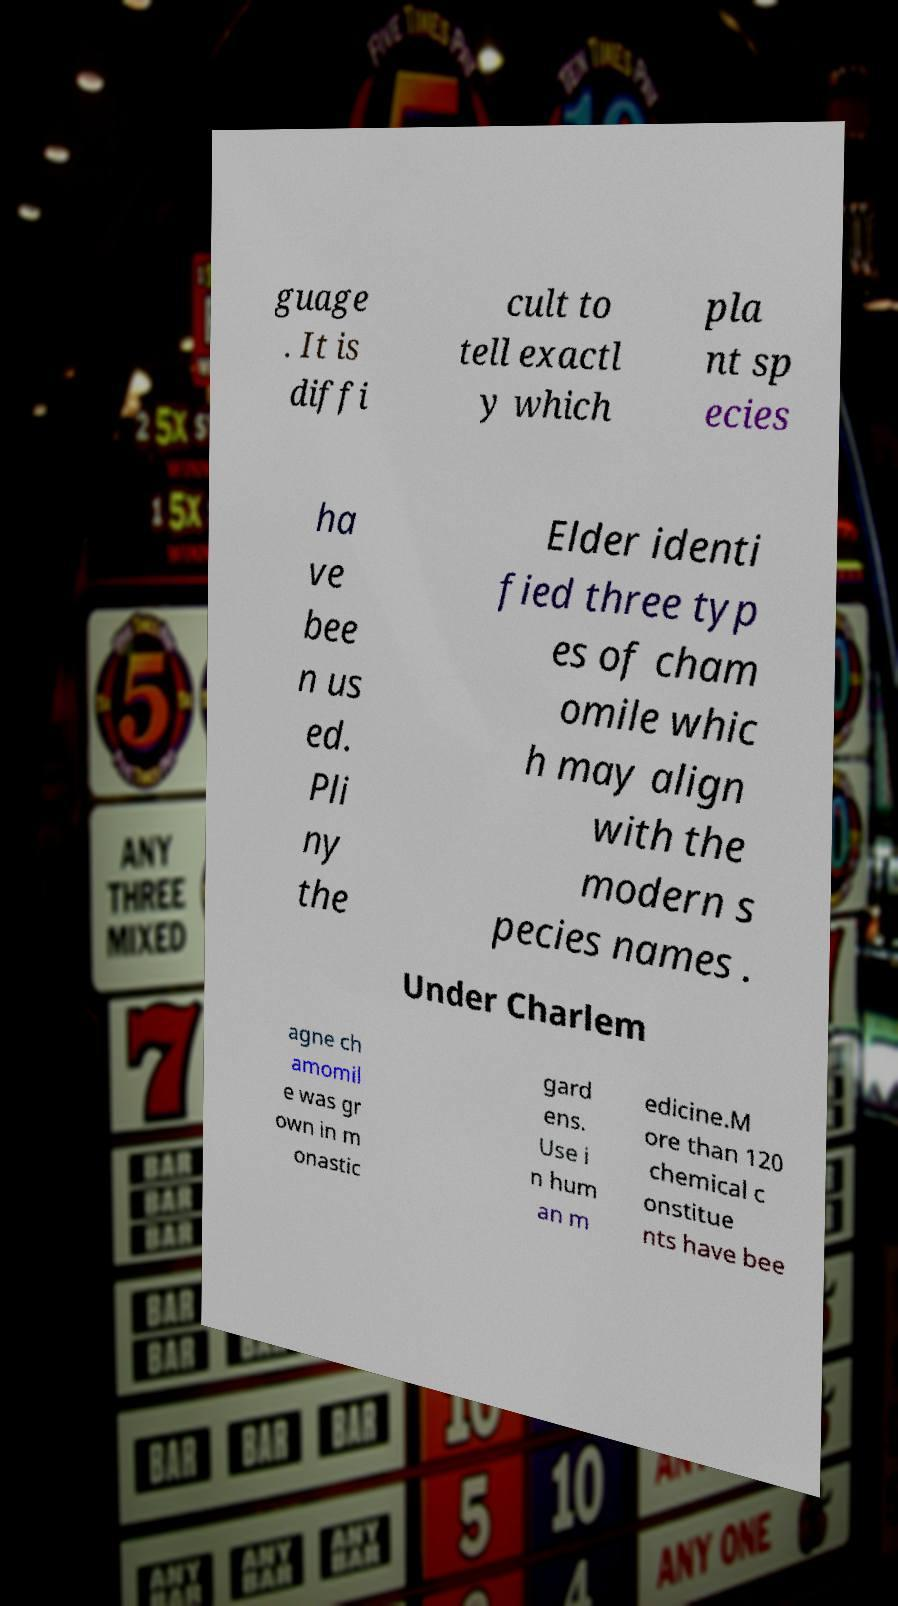Could you extract and type out the text from this image? guage . It is diffi cult to tell exactl y which pla nt sp ecies ha ve bee n us ed. Pli ny the Elder identi fied three typ es of cham omile whic h may align with the modern s pecies names . Under Charlem agne ch amomil e was gr own in m onastic gard ens. Use i n hum an m edicine.M ore than 120 chemical c onstitue nts have bee 